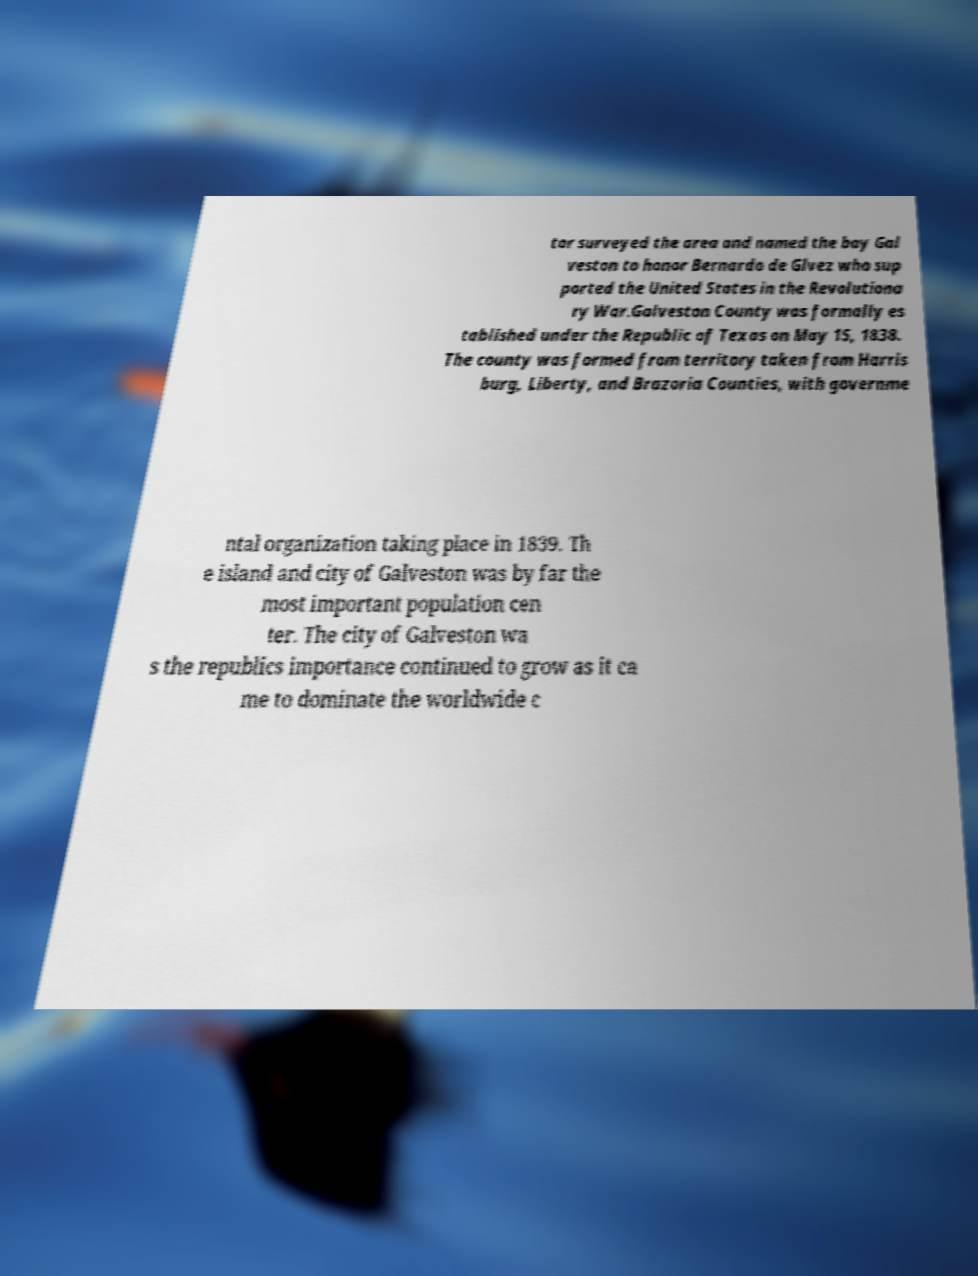For documentation purposes, I need the text within this image transcribed. Could you provide that? tor surveyed the area and named the bay Gal veston to honor Bernardo de Glvez who sup ported the United States in the Revolutiona ry War.Galveston County was formally es tablished under the Republic of Texas on May 15, 1838. The county was formed from territory taken from Harris burg, Liberty, and Brazoria Counties, with governme ntal organization taking place in 1839. Th e island and city of Galveston was by far the most important population cen ter. The city of Galveston wa s the republics importance continued to grow as it ca me to dominate the worldwide c 